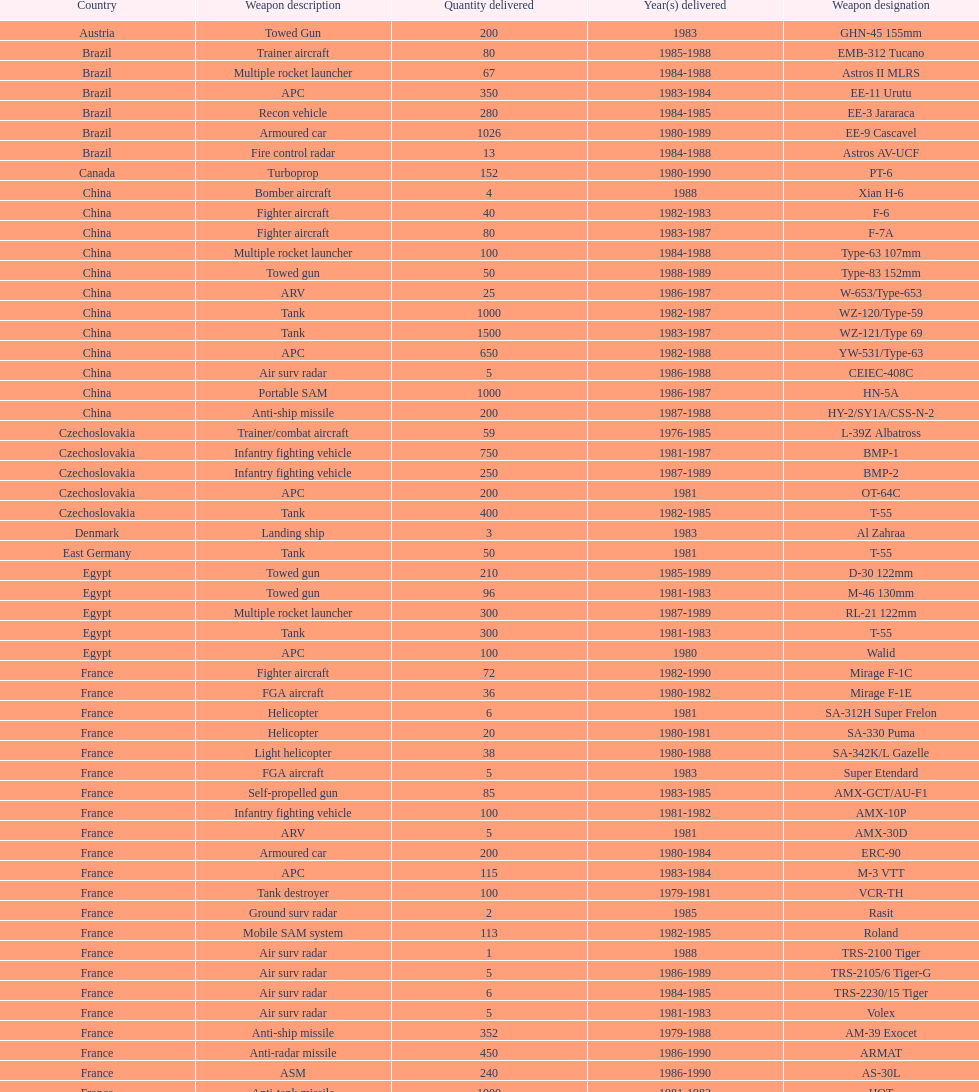Which was the first country to sell weapons to iraq? Czechoslovakia. Can you parse all the data within this table? {'header': ['Country', 'Weapon description', 'Quantity delivered', 'Year(s) delivered', 'Weapon designation'], 'rows': [['Austria', 'Towed Gun', '200', '1983', 'GHN-45 155mm'], ['Brazil', 'Trainer aircraft', '80', '1985-1988', 'EMB-312 Tucano'], ['Brazil', 'Multiple rocket launcher', '67', '1984-1988', 'Astros II MLRS'], ['Brazil', 'APC', '350', '1983-1984', 'EE-11 Urutu'], ['Brazil', 'Recon vehicle', '280', '1984-1985', 'EE-3 Jararaca'], ['Brazil', 'Armoured car', '1026', '1980-1989', 'EE-9 Cascavel'], ['Brazil', 'Fire control radar', '13', '1984-1988', 'Astros AV-UCF'], ['Canada', 'Turboprop', '152', '1980-1990', 'PT-6'], ['China', 'Bomber aircraft', '4', '1988', 'Xian H-6'], ['China', 'Fighter aircraft', '40', '1982-1983', 'F-6'], ['China', 'Fighter aircraft', '80', '1983-1987', 'F-7A'], ['China', 'Multiple rocket launcher', '100', '1984-1988', 'Type-63 107mm'], ['China', 'Towed gun', '50', '1988-1989', 'Type-83 152mm'], ['China', 'ARV', '25', '1986-1987', 'W-653/Type-653'], ['China', 'Tank', '1000', '1982-1987', 'WZ-120/Type-59'], ['China', 'Tank', '1500', '1983-1987', 'WZ-121/Type 69'], ['China', 'APC', '650', '1982-1988', 'YW-531/Type-63'], ['China', 'Air surv radar', '5', '1986-1988', 'CEIEC-408C'], ['China', 'Portable SAM', '1000', '1986-1987', 'HN-5A'], ['China', 'Anti-ship missile', '200', '1987-1988', 'HY-2/SY1A/CSS-N-2'], ['Czechoslovakia', 'Trainer/combat aircraft', '59', '1976-1985', 'L-39Z Albatross'], ['Czechoslovakia', 'Infantry fighting vehicle', '750', '1981-1987', 'BMP-1'], ['Czechoslovakia', 'Infantry fighting vehicle', '250', '1987-1989', 'BMP-2'], ['Czechoslovakia', 'APC', '200', '1981', 'OT-64C'], ['Czechoslovakia', 'Tank', '400', '1982-1985', 'T-55'], ['Denmark', 'Landing ship', '3', '1983', 'Al Zahraa'], ['East Germany', 'Tank', '50', '1981', 'T-55'], ['Egypt', 'Towed gun', '210', '1985-1989', 'D-30 122mm'], ['Egypt', 'Towed gun', '96', '1981-1983', 'M-46 130mm'], ['Egypt', 'Multiple rocket launcher', '300', '1987-1989', 'RL-21 122mm'], ['Egypt', 'Tank', '300', '1981-1983', 'T-55'], ['Egypt', 'APC', '100', '1980', 'Walid'], ['France', 'Fighter aircraft', '72', '1982-1990', 'Mirage F-1C'], ['France', 'FGA aircraft', '36', '1980-1982', 'Mirage F-1E'], ['France', 'Helicopter', '6', '1981', 'SA-312H Super Frelon'], ['France', 'Helicopter', '20', '1980-1981', 'SA-330 Puma'], ['France', 'Light helicopter', '38', '1980-1988', 'SA-342K/L Gazelle'], ['France', 'FGA aircraft', '5', '1983', 'Super Etendard'], ['France', 'Self-propelled gun', '85', '1983-1985', 'AMX-GCT/AU-F1'], ['France', 'Infantry fighting vehicle', '100', '1981-1982', 'AMX-10P'], ['France', 'ARV', '5', '1981', 'AMX-30D'], ['France', 'Armoured car', '200', '1980-1984', 'ERC-90'], ['France', 'APC', '115', '1983-1984', 'M-3 VTT'], ['France', 'Tank destroyer', '100', '1979-1981', 'VCR-TH'], ['France', 'Ground surv radar', '2', '1985', 'Rasit'], ['France', 'Mobile SAM system', '113', '1982-1985', 'Roland'], ['France', 'Air surv radar', '1', '1988', 'TRS-2100 Tiger'], ['France', 'Air surv radar', '5', '1986-1989', 'TRS-2105/6 Tiger-G'], ['France', 'Air surv radar', '6', '1984-1985', 'TRS-2230/15 Tiger'], ['France', 'Air surv radar', '5', '1981-1983', 'Volex'], ['France', 'Anti-ship missile', '352', '1979-1988', 'AM-39 Exocet'], ['France', 'Anti-radar missile', '450', '1986-1990', 'ARMAT'], ['France', 'ASM', '240', '1986-1990', 'AS-30L'], ['France', 'Anti-tank missile', '1000', '1981-1982', 'HOT'], ['France', 'SRAAM', '534', '1981-1985', 'R-550 Magic-1'], ['France', 'SAM', '2260', '1981-1990', 'Roland-2'], ['France', 'BVRAAM', '300', '1981-1985', 'Super 530F'], ['West Germany', 'Helicopter', '22', '1984-1989', 'BK-117'], ['West Germany', 'Light Helicopter', '20', '1979-1982', 'Bo-105C'], ['West Germany', 'Light Helicopter', '6', '1988', 'Bo-105L'], ['Hungary', 'APC', '300', '1981', 'PSZH-D-994'], ['Italy', 'Light Helicopter', '2', '1982', 'A-109 Hirundo'], ['Italy', 'Helicopter', '6', '1982', 'S-61'], ['Italy', 'Support ship', '1', '1981', 'Stromboli class'], ['Jordan', 'Helicopter', '2', '1985', 'S-76 Spirit'], ['Poland', 'Helicopter', '15', '1984-1985', 'Mi-2/Hoplite'], ['Poland', 'APC', '750', '1983-1990', 'MT-LB'], ['Poland', 'Tank', '400', '1981-1982', 'T-55'], ['Poland', 'Tank', '500', '1982-1990', 'T-72M1'], ['Romania', 'Tank', '150', '1982-1984', 'T-55'], ['Yugoslavia', 'Multiple rocket launcher', '2', '1988', 'M-87 Orkan 262mm'], ['South Africa', 'Towed gun', '200', '1985-1988', 'G-5 155mm'], ['Switzerland', 'Trainer aircraft', '52', '1980-1983', 'PC-7 Turbo trainer'], ['Switzerland', 'Trainer aircraft', '20', '1987-1990', 'PC-9'], ['Switzerland', 'APC/IFV', '100', '1981', 'Roland'], ['United Kingdom', 'ARV', '29', '1982', 'Chieftain/ARV'], ['United Kingdom', 'Arty locating radar', '10', '1986-1988', 'Cymbeline'], ['United States', 'Light Helicopter', '30', '1983', 'MD-500MD Defender'], ['United States', 'Light Helicopter', '30', '1983', 'Hughes-300/TH-55'], ['United States', 'Light Helicopter', '26', '1986', 'MD-530F'], ['United States', 'Helicopter', '31', '1988', 'Bell 214ST'], ['Soviet Union', 'Strategic airlifter', '33', '1978-1984', 'Il-76M/Candid-B'], ['Soviet Union', 'Attack helicopter', '12', '1978-1984', 'Mi-24D/Mi-25/Hind-D'], ['Soviet Union', 'Transport helicopter', '37', '1986-1987', 'Mi-8/Mi-17/Hip-H'], ['Soviet Union', 'Transport helicopter', '30', '1984', 'Mi-8TV/Hip-F'], ['Soviet Union', 'Fighter aircraft', '61', '1983-1984', 'Mig-21bis/Fishbed-N'], ['Soviet Union', 'FGA aircraft', '50', '1984-1985', 'Mig-23BN/Flogger-H'], ['Soviet Union', 'Interceptor aircraft', '55', '1980-1985', 'Mig-25P/Foxbat-A'], ['Soviet Union', 'Recon aircraft', '8', '1982', 'Mig-25RB/Foxbat-B'], ['Soviet Union', 'Fighter aircraft', '41', '1986-1989', 'Mig-29/Fulcrum-A'], ['Soviet Union', 'FGA aircraft', '61', '1986-1987', 'Su-22/Fitter-H/J/K'], ['Soviet Union', 'Ground attack aircraft', '84', '1986-1987', 'Su-25/Frogfoot-A'], ['Soviet Union', 'Towed gun', '180', '1986-1988', '2A36 152mm'], ['Soviet Union', 'Self-Propelled Howitzer', '150', '1980-1989', '2S1 122mm'], ['Soviet Union', 'Self-propelled gun', '150', '1980-1989', '2S3 152mm'], ['Soviet Union', 'Self-propelled mortar', '10', '1983', '2S4 240mm'], ['Soviet Union', 'SSM launcher', '10', '1983-1984', '9P117/SS-1 Scud TEL'], ['Soviet Union', 'Multiple rocket launcher', '560', '1983-1988', 'BM-21 Grad 122mm'], ['Soviet Union', 'Towed gun', '576', '1982-1988', 'D-30 122mm'], ['Soviet Union', 'Mortar', '25', '1981', 'M-240 240mm'], ['Soviet Union', 'Towed Gun', '576', '1982-1987', 'M-46 130mm'], ['Soviet Union', 'AAV(M)', '30', '1985', '9K35 Strela-10/SA-13'], ['Soviet Union', 'IFV', '10', '1981', 'BMD-1'], ['Soviet Union', 'Light tank', '200', '1984', 'PT-76'], ['Soviet Union', 'AAV(M)', '160', '1982-1985', 'SA-9/9P31'], ['Soviet Union', 'Air surv radar', '10', '1980-1984', 'Long Track'], ['Soviet Union', 'Mobile SAM system', '50', '1982-1985', 'SA-8b/9K33M Osa AK'], ['Soviet Union', 'Air surv radar', '5', '1980-1984', 'Thin Skin'], ['Soviet Union', 'Anti-tank missile', '3000', '1986-1989', '9M111/AT-4 Spigot'], ['Soviet Union', 'SAM', '960', '1985-1986', '9M37/SA-13 Gopher'], ['Soviet Union', 'Anti-ship missile', '36', '1984', 'KSR-5/AS-6 Kingfish'], ['Soviet Union', 'Anti-radar missile', '250', '1983-1988', 'Kh-28/AS-9 Kyle'], ['Soviet Union', 'SRAAM', '1080', '1984-1987', 'R-13S/AA2S Atoll'], ['Soviet Union', 'SSM', '840', '1982-1988', 'R-17/SS-1c Scud-B'], ['Soviet Union', 'BVRAAM', '246', '1986-1989', 'R-27/AA-10 Alamo'], ['Soviet Union', 'BVRAAM', '660', '1980-1985', 'R-40R/AA-6 Acrid'], ['Soviet Union', 'SRAAM', '582', '1986-1989', 'R-60/AA-8 Aphid'], ['Soviet Union', 'SAM', '1290', '1982-1985', 'SA-8b Gecko/9M33M'], ['Soviet Union', 'SAM', '1920', '1982-1985', 'SA-9 Gaskin/9M31'], ['Soviet Union', 'Portable SAM', '500', '1987-1988', 'Strela-3/SA-14 Gremlin']]} 